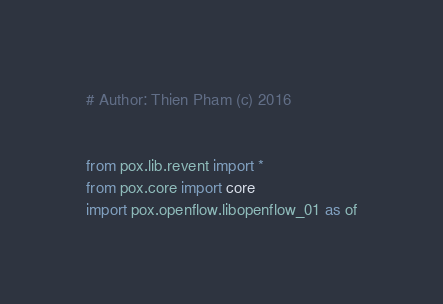<code> <loc_0><loc_0><loc_500><loc_500><_Python_># Author: Thien Pham (c) 2016


from pox.lib.revent import *
from pox.core import core
import pox.openflow.libopenflow_01 as of</code> 